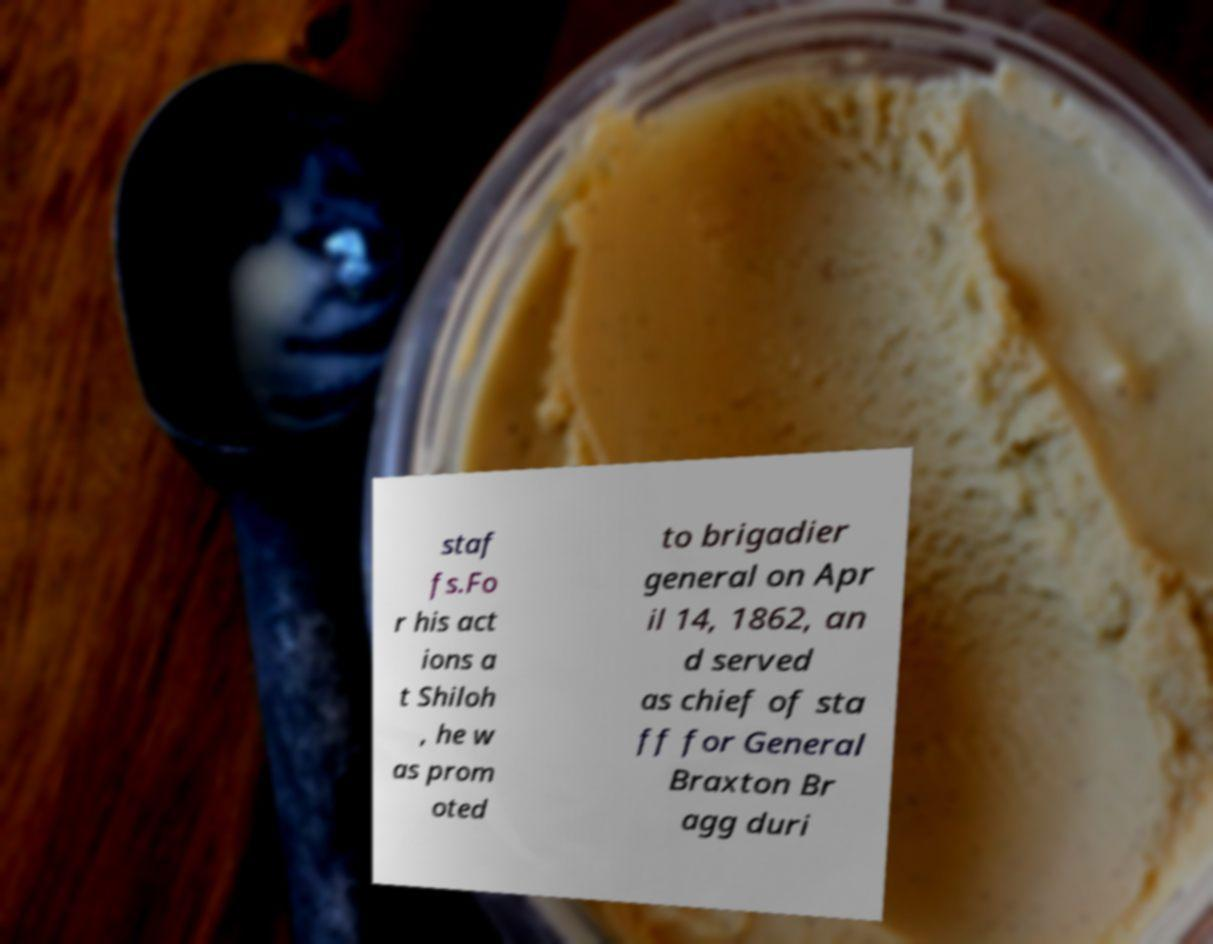Please identify and transcribe the text found in this image. staf fs.Fo r his act ions a t Shiloh , he w as prom oted to brigadier general on Apr il 14, 1862, an d served as chief of sta ff for General Braxton Br agg duri 